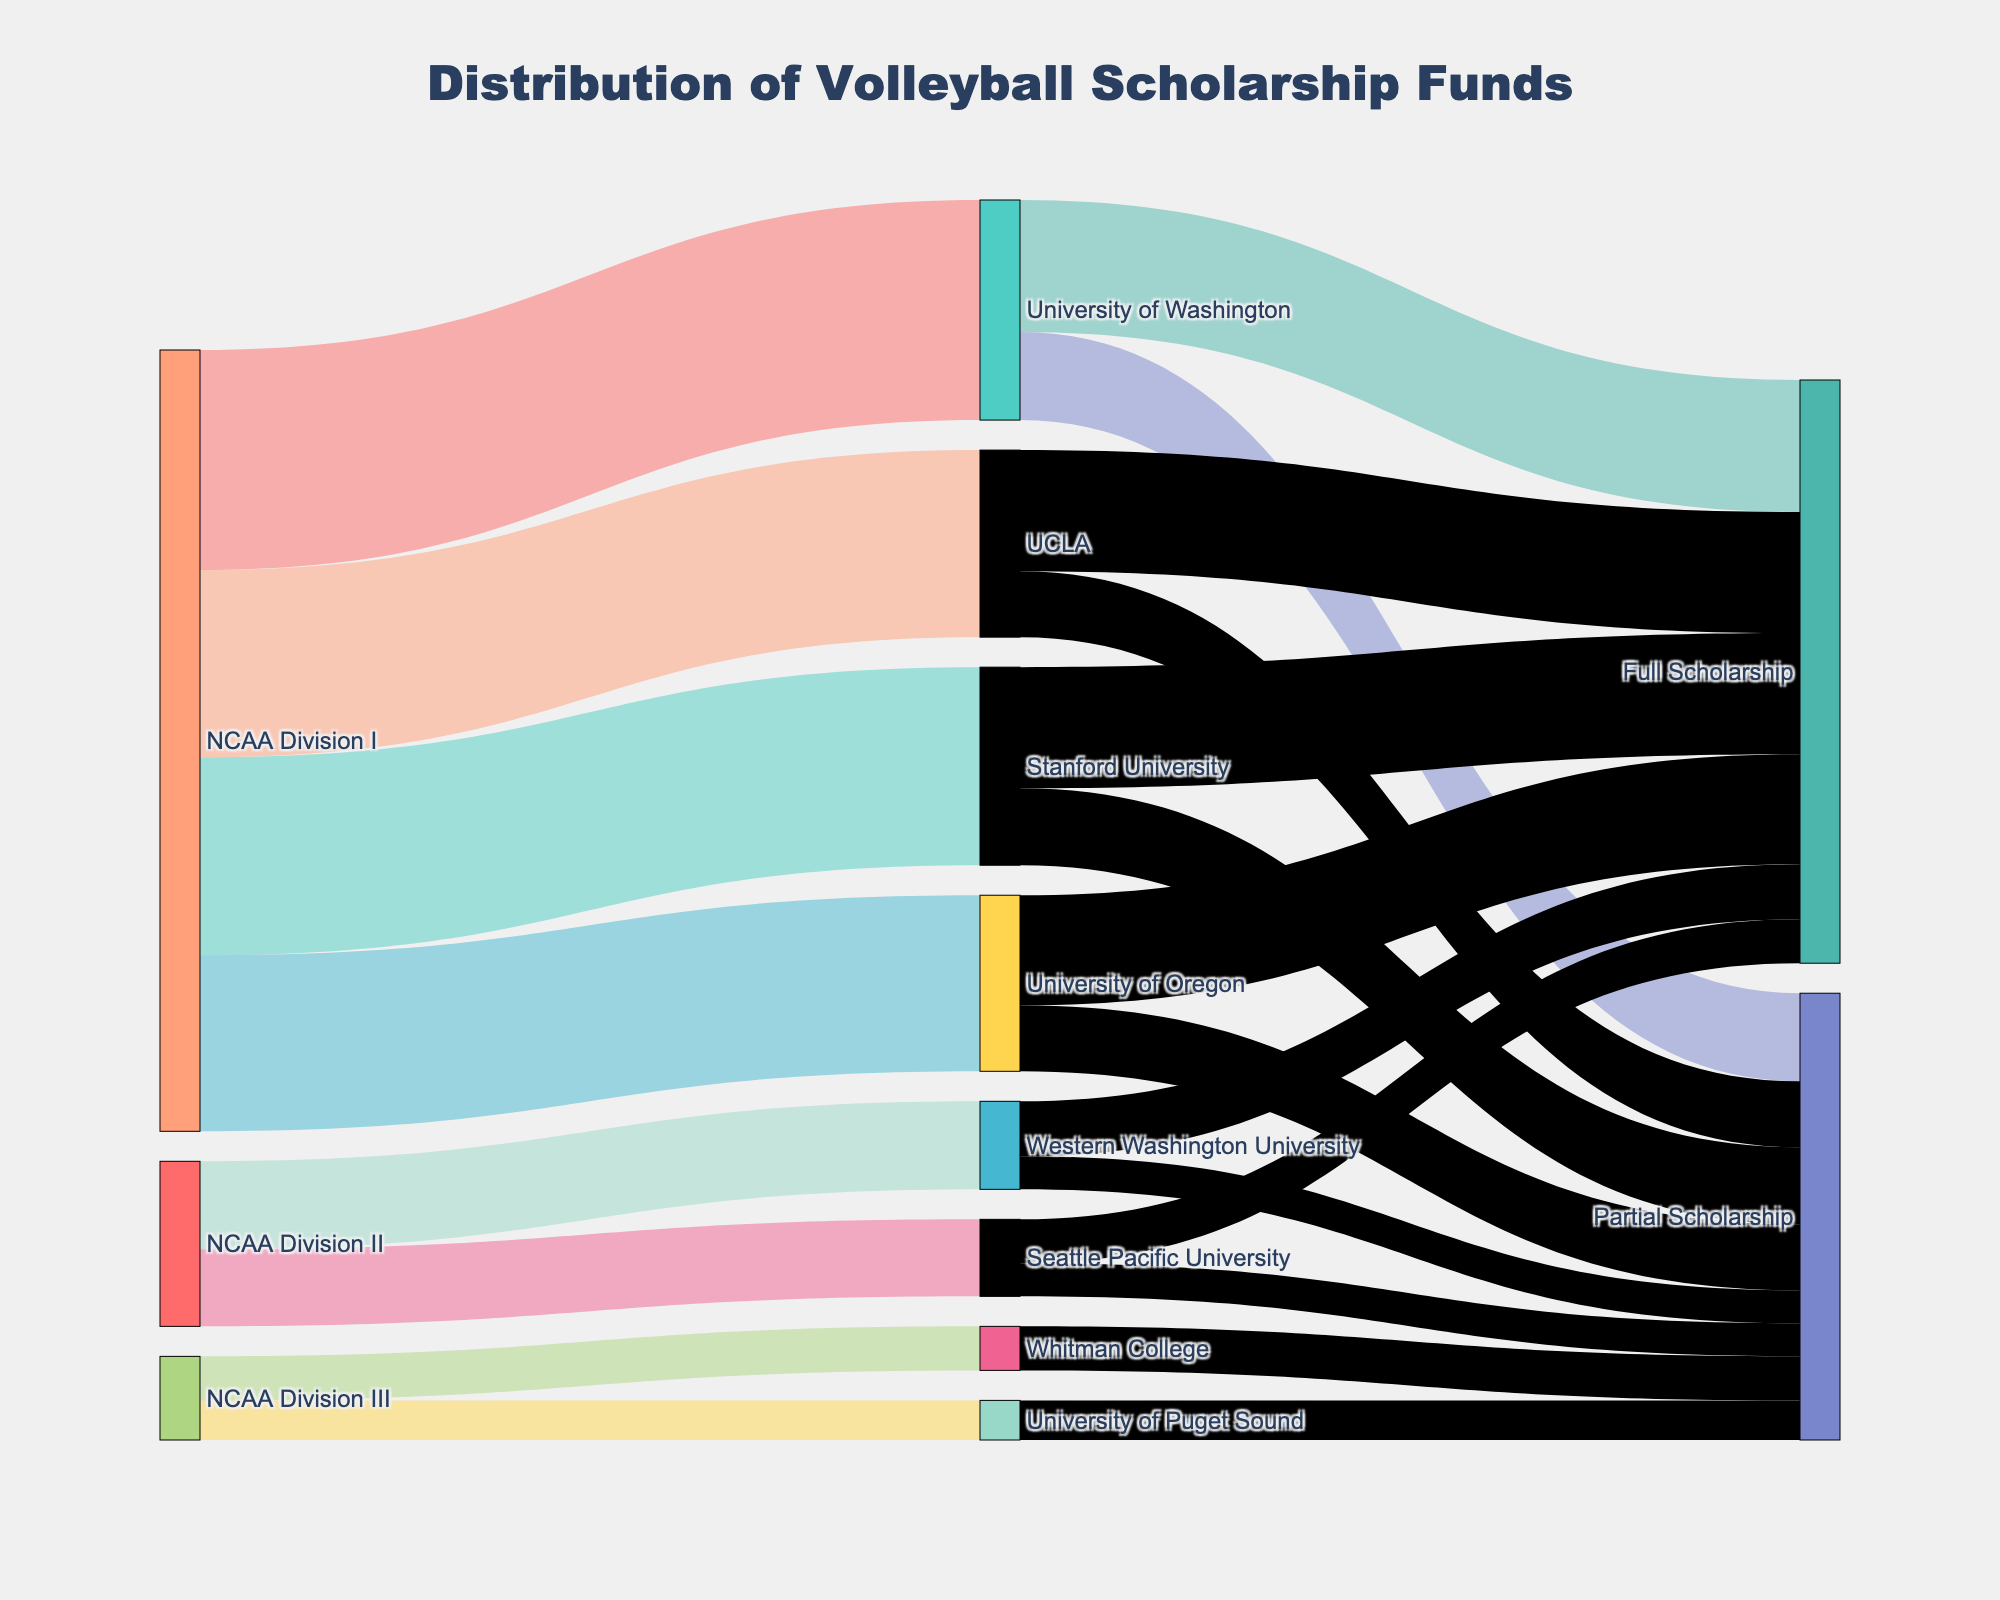What is the title of the Sankey diagram? The title of the diagram is typically prominently displayed at the top and specifies what the diagram represents.
Answer: Distribution of Volleyball Scholarship Funds How many colleges and universities are shown in NCAA Division I? In the figure, each node represents a college or university, and by counting these nodes within the NCAA Division I section, we determine the number.
Answer: 4 Which college in NCAA Division III receives the least scholarship funds? By comparing the values of the scholarships shown flowing into each NCAA Division III college, we can identify the smallest amount.
Answer: University of Puget Sound What is the total amount of scholarship funds allocated to NCAA Division II? We need to sum the values from Western Washington University and Seattle Pacific University, which are under NCAA Division II.
Answer: 375,000 Which college provides the highest amount of full scholarships? Compare the values of full scholarships among all colleges to find the one with the highest value.
Answer: Stanford University What is the difference between full and partial scholarships at the University of Washington? Subtract the value of partial scholarships from the value of full scholarships at the University of Washington.
Answer: 100,000 Does Stanford University offer more or less in partial scholarships than UCLA? Compare the partial scholarship values for Stanford University and UCLA to determine which is higher.
Answer: More What percentage of the total funds for the University of Washington are allocated to full scholarships? Calculate the percentage by dividing the full scholarship amount by the total scholarship amount for the University of Washington and multiplying by 100.
Answer: 60% What is the combined amount of scholarships received by Whitman College and the University of Puget Sound? Add the scholarship values of Whitman College and University of Puget Sound.
Answer: 190,000 Which division, NCAA Division I or NCAA Division II, distributes more total scholarship funds? Sum the scholarship funds for each division and compare the totals.
Answer: NCAA Division I 